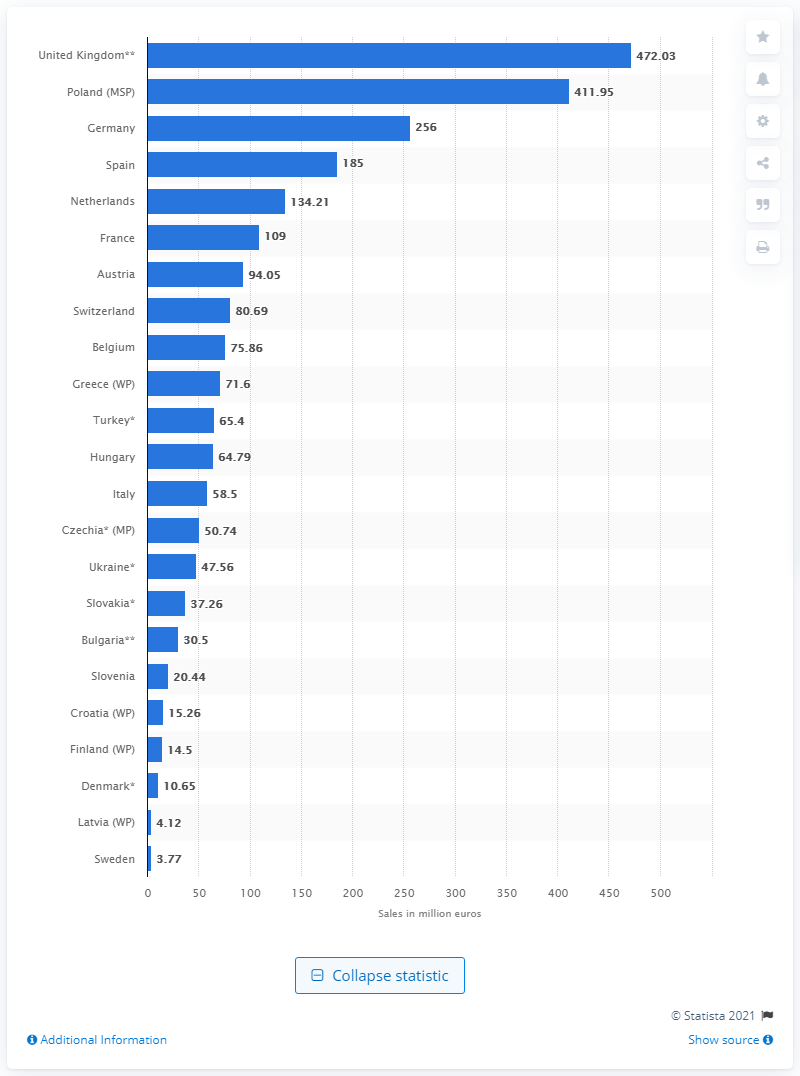Point out several critical features in this image. Sweden had the lowest sales of vitamins and minerals out of all countries. 